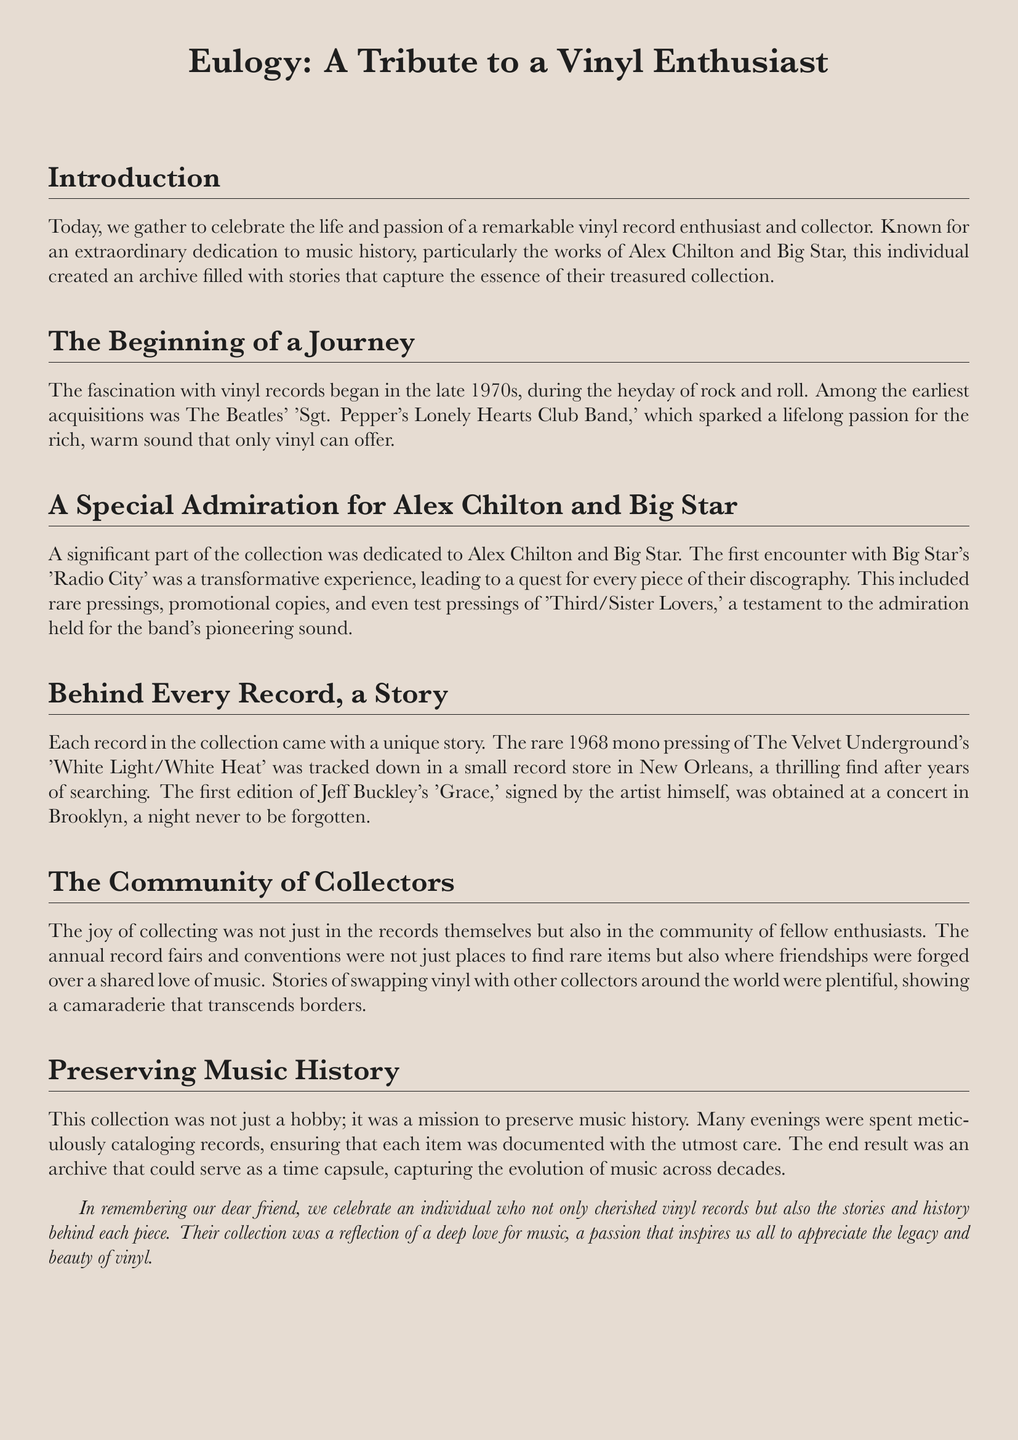What was the first vinyl record mentioned? The document states that the fascination began with The Beatles' 'Sgt. Pepper's Lonely Hearts Club Band.'
Answer: 'Sgt. Pepper's Lonely Hearts Club Band' Who is the artist associated with the significant part of the collection? The document mentions Alex Chilton and Big Star as the main focus of the collection.
Answer: Alex Chilton and Big Star What type of pressing of 'White Light/White Heat' was found? The document specifies that a rare 1968 mono pressing was tracked down.
Answer: 1968 mono pressing How was the signed copy of 'Grace' obtained? It states that it was obtained at a concert in Brooklyn.
Answer: At a concert in Brooklyn What was spent on cataloging the records? The document describes evenings spent meticulously cataloging records.
Answer: Evenings What did record fairs represent for the collector? The document indicates that record fairs were places for friendships forged over shared love of music.
Answer: Friendships How did the collector view their mission? The text asserts that the collection was a mission to preserve music history.
Answer: Preserve music history What does the document imply about the collection? It suggests that the collection serves as a time capsule, capturing the evolution of music.
Answer: Time capsule 